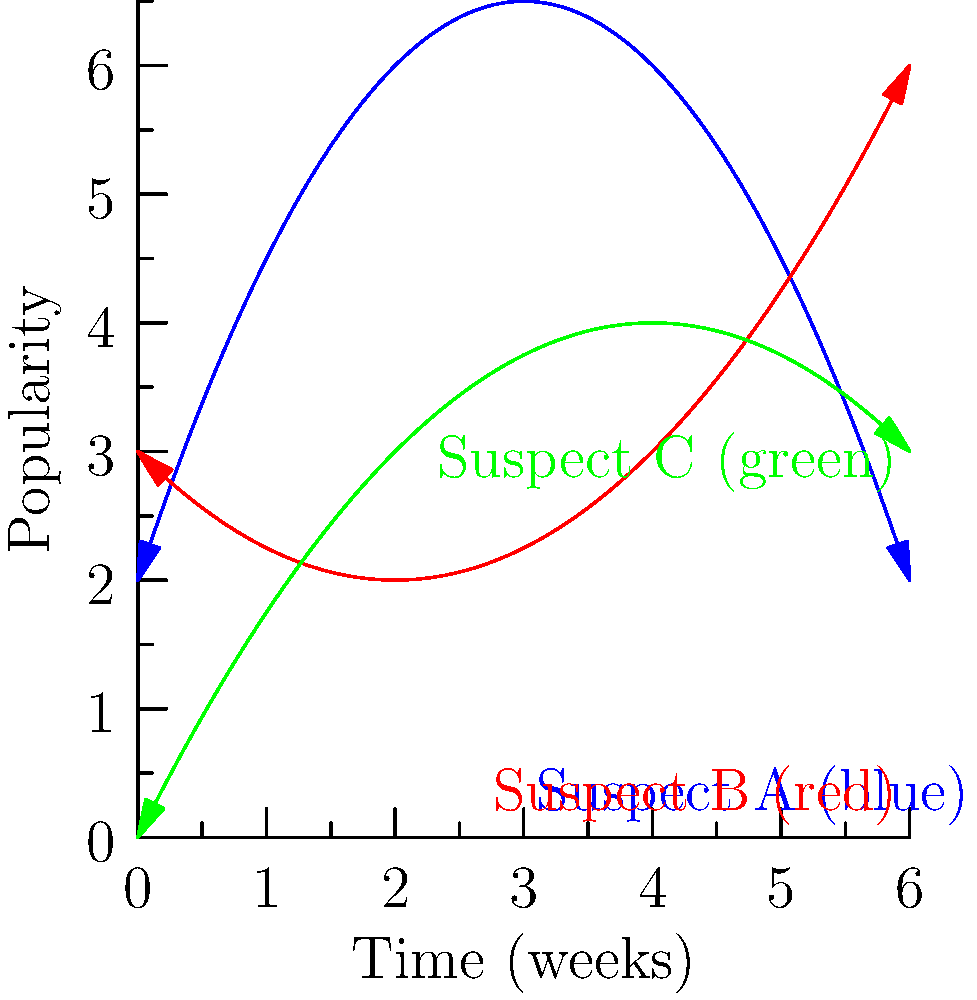In your latest crime novel, you've plotted the popularity of three suspects over time based on your grandparent's recollection of a notorious case from their youth. The graph shows the popularity curves for Suspects A, B, and C over six weeks. Which suspect reaches their peak popularity latest, and at approximately what time does this occur? To solve this problem, we need to analyze each suspect's popularity curve:

1. Suspect A (blue curve):
   - This is a parabola opening downwards.
   - Its vertex (maximum point) occurs early, around 3 weeks.

2. Suspect B (red curve):
   - This is a parabola opening upwards.
   - Its minimum point is around 2 weeks, and it keeps increasing.
   - The maximum within the given time frame is at the end (6 weeks).

3. Suspect C (green curve):
   - This is a parabola opening downwards.
   - Its vertex (maximum point) occurs around 4 weeks.

Comparing these:
- Suspect A peaks earliest (around 3 weeks)
- Suspect C peaks second (around 4 weeks)
- Suspect B's popularity is still increasing at 6 weeks

Therefore, Suspect B reaches their peak popularity latest, at approximately 6 weeks (the end of the given time frame).
Answer: Suspect B, at 6 weeks 